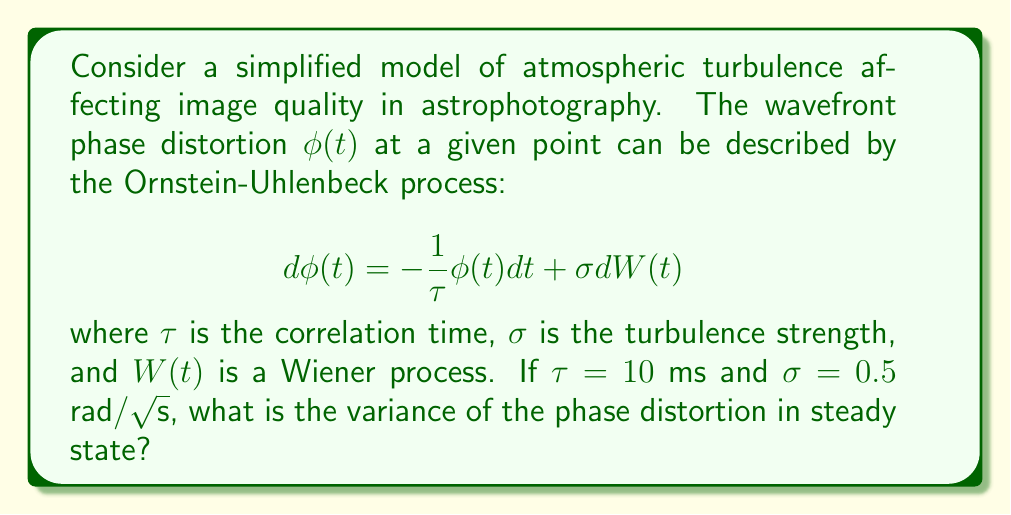Provide a solution to this math problem. To solve this problem, we'll follow these steps:

1) The Ornstein-Uhlenbeck process describes a mean-reverting process. In steady state, the variance of this process is given by:

   $$\text{Var}(\phi) = \frac{\sigma^2\tau}{2}$$

2) We're given:
   $\tau = 10$ ms $= 0.01$ s
   $\sigma = 0.5$ rad/√s

3) Let's substitute these values into the variance formula:

   $$\text{Var}(\phi) = \frac{(0.5\text{ rad}/\sqrt{\text{s}})^2 \cdot 0.01\text{ s}}{2}$$

4) Simplify:
   $$\text{Var}(\phi) = \frac{0.25\text{ rad}^2/\text{s} \cdot 0.01\text{ s}}{2} = 0.00125\text{ rad}^2$$

5) Therefore, the variance of the phase distortion in steady state is 0.00125 rad².

This value represents the expected squared deviation of the wavefront phase from its mean, which directly affects the image quality in astrophotography.
Answer: 0.00125 rad² 